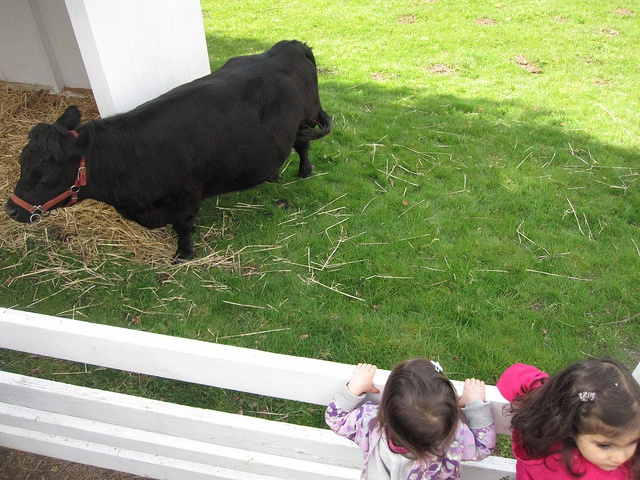Describe the objects in this image and their specific colors. I can see cow in gray, black, darkgreen, and maroon tones, people in gray, lightgray, darkgray, and black tones, and people in gray, black, maroon, and brown tones in this image. 